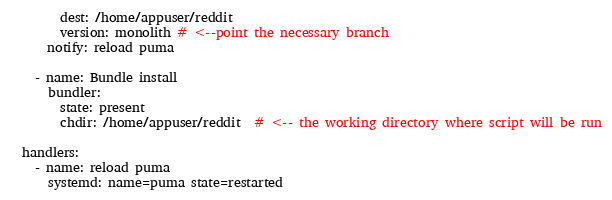<code> <loc_0><loc_0><loc_500><loc_500><_YAML_>        dest: /home/appuser/reddit
        version: monolith # <--point the necessary branch
      notify: reload puma

    - name: Bundle install
      bundler:
        state: present
        chdir: /home/appuser/reddit  # <-- the working directory where script will be run

  handlers:
    - name: reload puma
      systemd: name=puma state=restarted

</code> 